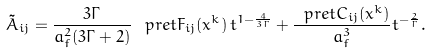<formula> <loc_0><loc_0><loc_500><loc_500>\tilde { A } _ { i j } = \frac { 3 \Gamma } { a _ { f } ^ { 2 } ( 3 \Gamma + 2 ) } \, \ p r e t F _ { i j } ( x ^ { k } ) \, t ^ { 1 - \frac { 4 } { 3 \Gamma } } + \frac { \ p r e t C _ { i j } ( x ^ { k } ) } { a _ { f } ^ { 3 } } t ^ { - \frac { 2 } { \Gamma } } .</formula> 